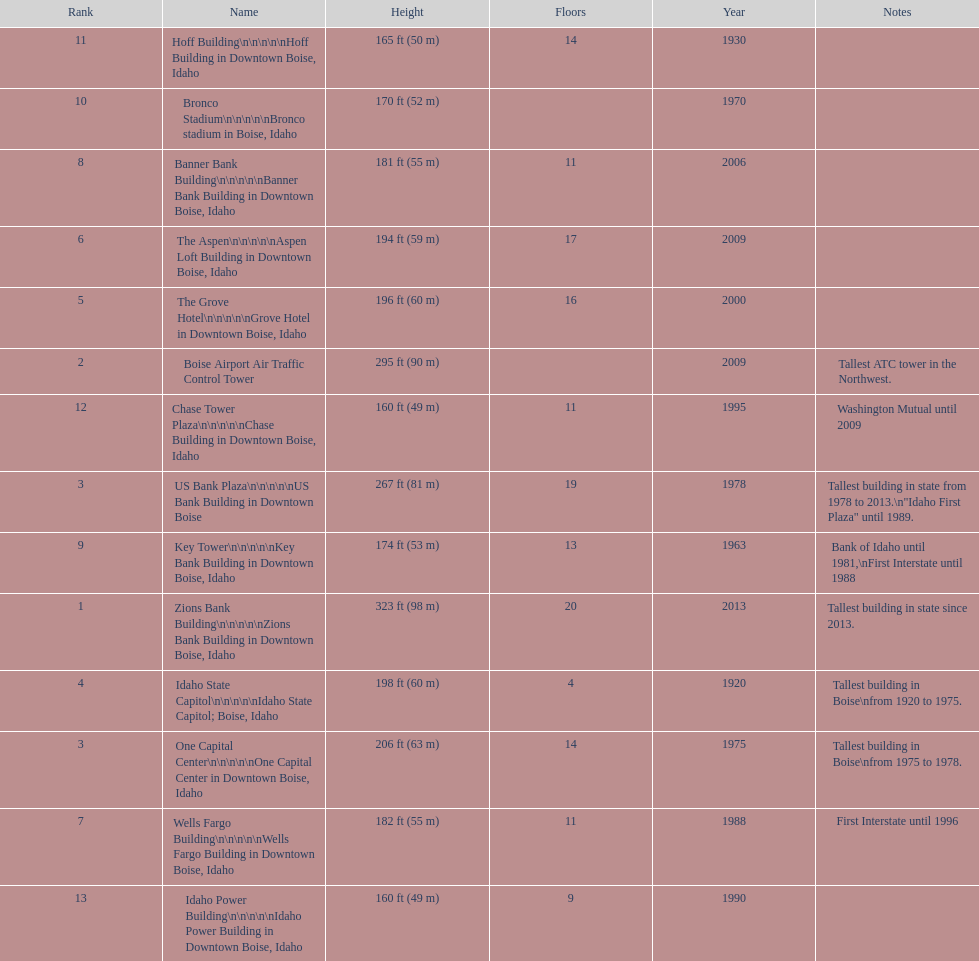What is the name of the building listed after idaho state capitol? The Grove Hotel. 